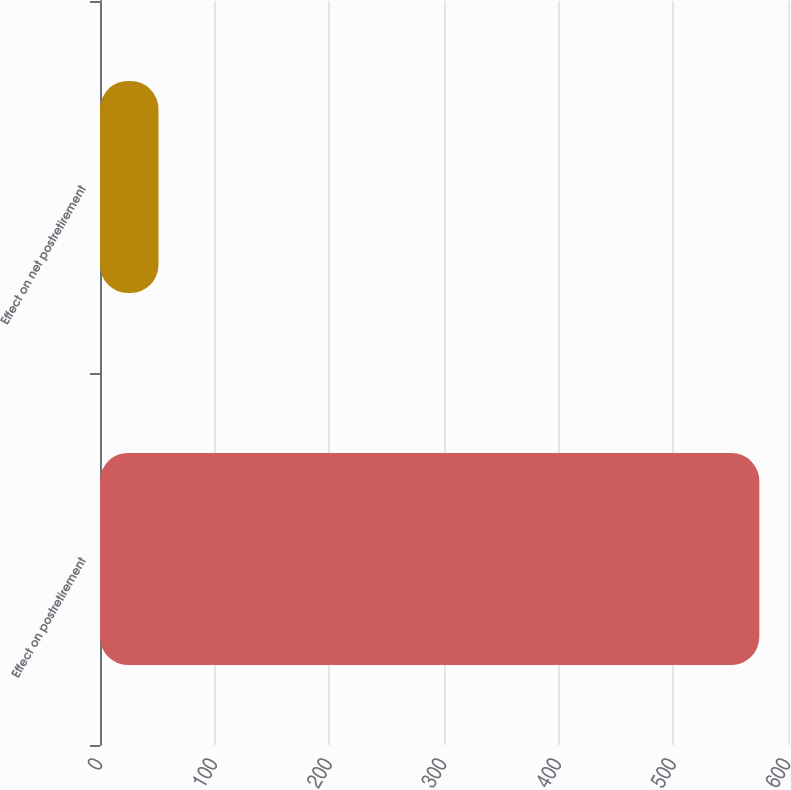Convert chart to OTSL. <chart><loc_0><loc_0><loc_500><loc_500><bar_chart><fcel>Effect on postretirement<fcel>Effect on net postretirement<nl><fcel>575<fcel>51<nl></chart> 